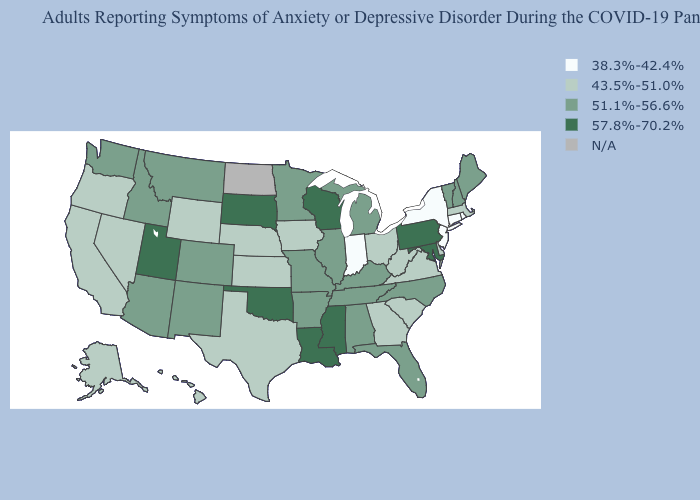Does the first symbol in the legend represent the smallest category?
Be succinct. Yes. What is the value of Indiana?
Answer briefly. 38.3%-42.4%. Among the states that border Connecticut , does New York have the highest value?
Answer briefly. No. Name the states that have a value in the range N/A?
Short answer required. North Dakota. Does the map have missing data?
Answer briefly. Yes. Name the states that have a value in the range 51.1%-56.6%?
Keep it brief. Alabama, Arizona, Arkansas, Colorado, Florida, Idaho, Illinois, Kentucky, Maine, Michigan, Minnesota, Missouri, Montana, New Hampshire, New Mexico, North Carolina, Tennessee, Vermont, Washington. Does West Virginia have the highest value in the USA?
Answer briefly. No. What is the highest value in the West ?
Give a very brief answer. 57.8%-70.2%. Which states have the lowest value in the USA?
Short answer required. Connecticut, Indiana, New Jersey, New York, Rhode Island. What is the lowest value in the USA?
Quick response, please. 38.3%-42.4%. Which states have the lowest value in the MidWest?
Keep it brief. Indiana. What is the lowest value in states that border Nevada?
Concise answer only. 43.5%-51.0%. Does Alaska have the lowest value in the West?
Short answer required. Yes. Name the states that have a value in the range 38.3%-42.4%?
Be succinct. Connecticut, Indiana, New Jersey, New York, Rhode Island. 